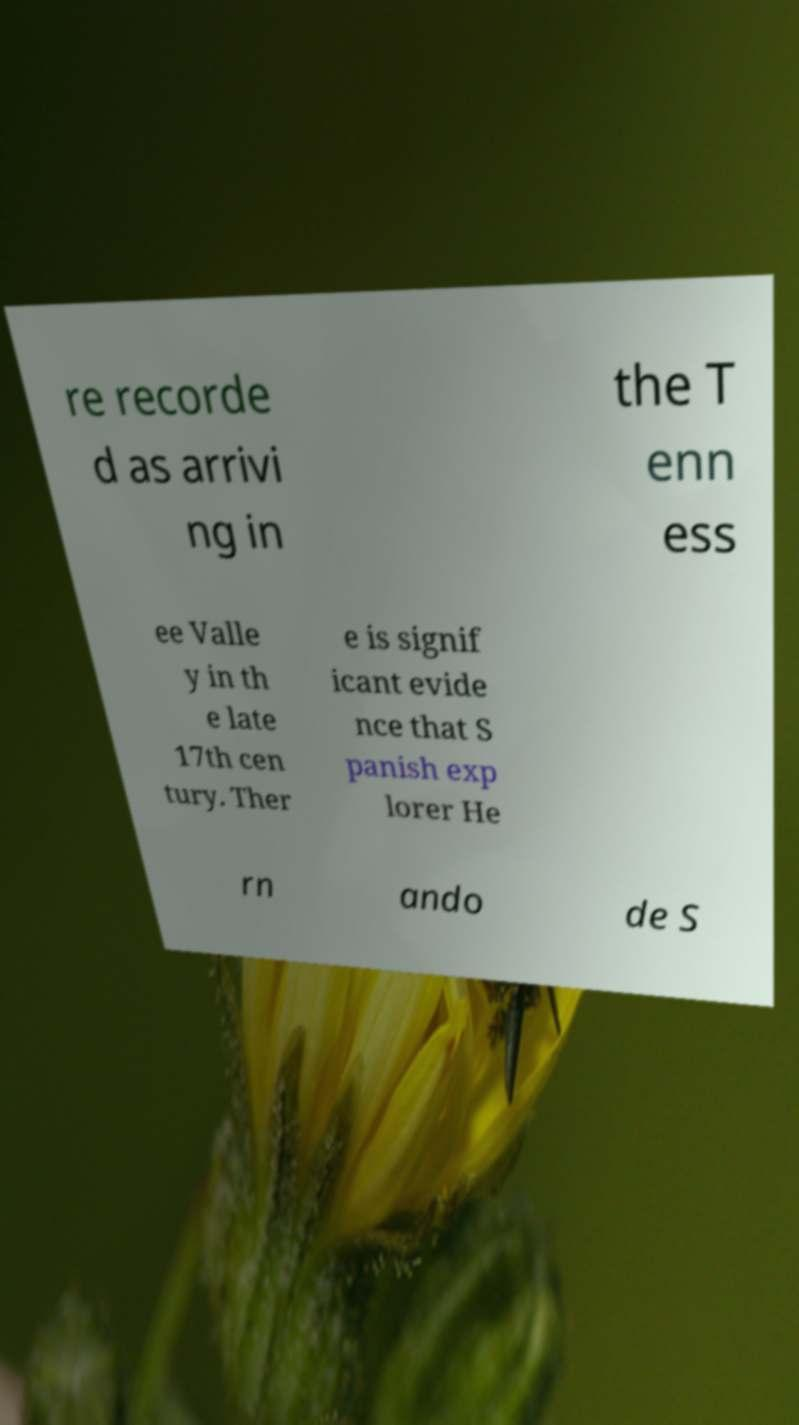I need the written content from this picture converted into text. Can you do that? re recorde d as arrivi ng in the T enn ess ee Valle y in th e late 17th cen tury. Ther e is signif icant evide nce that S panish exp lorer He rn ando de S 